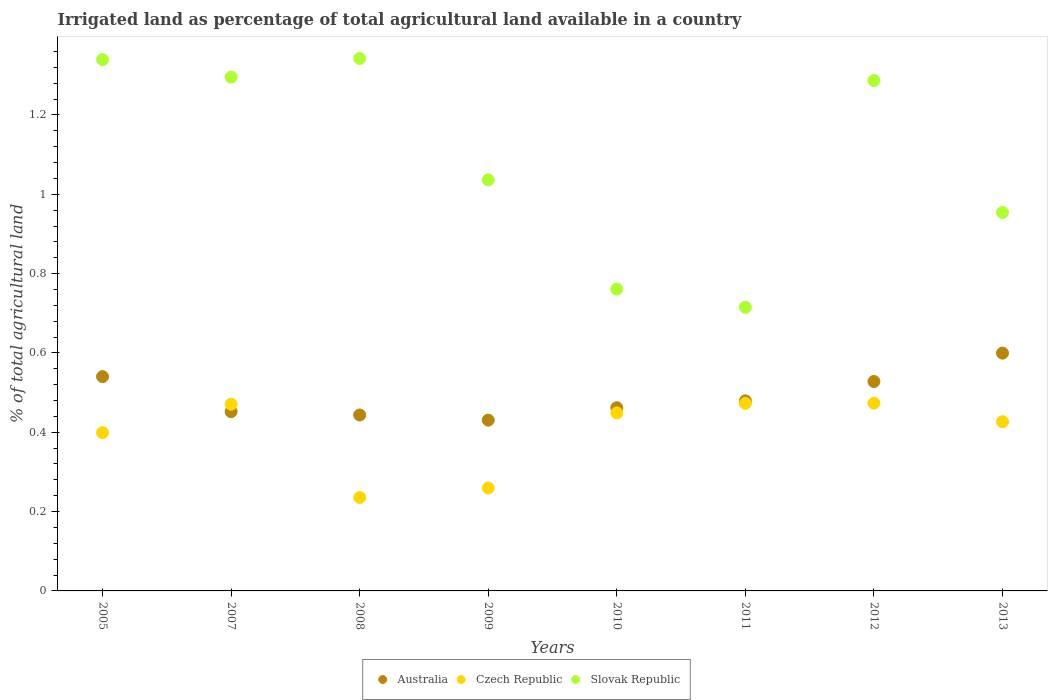How many different coloured dotlines are there?
Keep it short and to the point. 3. What is the percentage of irrigated land in Australia in 2010?
Provide a succinct answer. 0.46. Across all years, what is the maximum percentage of irrigated land in Australia?
Offer a very short reply. 0.6. Across all years, what is the minimum percentage of irrigated land in Australia?
Keep it short and to the point. 0.43. In which year was the percentage of irrigated land in Australia maximum?
Give a very brief answer. 2013. What is the total percentage of irrigated land in Australia in the graph?
Ensure brevity in your answer.  3.94. What is the difference between the percentage of irrigated land in Slovak Republic in 2011 and that in 2012?
Your response must be concise. -0.57. What is the difference between the percentage of irrigated land in Slovak Republic in 2009 and the percentage of irrigated land in Czech Republic in 2010?
Give a very brief answer. 0.59. What is the average percentage of irrigated land in Slovak Republic per year?
Provide a succinct answer. 1.09. In the year 2009, what is the difference between the percentage of irrigated land in Australia and percentage of irrigated land in Czech Republic?
Give a very brief answer. 0.17. What is the ratio of the percentage of irrigated land in Slovak Republic in 2008 to that in 2009?
Give a very brief answer. 1.3. Is the percentage of irrigated land in Slovak Republic in 2005 less than that in 2010?
Offer a terse response. No. Is the difference between the percentage of irrigated land in Australia in 2005 and 2007 greater than the difference between the percentage of irrigated land in Czech Republic in 2005 and 2007?
Make the answer very short. Yes. What is the difference between the highest and the second highest percentage of irrigated land in Czech Republic?
Your response must be concise. 0. What is the difference between the highest and the lowest percentage of irrigated land in Australia?
Provide a short and direct response. 0.17. In how many years, is the percentage of irrigated land in Australia greater than the average percentage of irrigated land in Australia taken over all years?
Keep it short and to the point. 3. Is the sum of the percentage of irrigated land in Australia in 2005 and 2007 greater than the maximum percentage of irrigated land in Czech Republic across all years?
Your answer should be very brief. Yes. Does the percentage of irrigated land in Czech Republic monotonically increase over the years?
Provide a succinct answer. No. Is the percentage of irrigated land in Australia strictly greater than the percentage of irrigated land in Slovak Republic over the years?
Your response must be concise. No. Does the graph contain any zero values?
Your answer should be very brief. No. Where does the legend appear in the graph?
Your answer should be compact. Bottom center. What is the title of the graph?
Provide a succinct answer. Irrigated land as percentage of total agricultural land available in a country. Does "Cuba" appear as one of the legend labels in the graph?
Provide a succinct answer. No. What is the label or title of the X-axis?
Give a very brief answer. Years. What is the label or title of the Y-axis?
Your answer should be compact. % of total agricultural land. What is the % of total agricultural land in Australia in 2005?
Ensure brevity in your answer.  0.54. What is the % of total agricultural land in Czech Republic in 2005?
Offer a very short reply. 0.4. What is the % of total agricultural land in Slovak Republic in 2005?
Keep it short and to the point. 1.34. What is the % of total agricultural land in Australia in 2007?
Provide a succinct answer. 0.45. What is the % of total agricultural land of Czech Republic in 2007?
Your answer should be very brief. 0.47. What is the % of total agricultural land of Slovak Republic in 2007?
Make the answer very short. 1.3. What is the % of total agricultural land in Australia in 2008?
Provide a short and direct response. 0.44. What is the % of total agricultural land of Czech Republic in 2008?
Make the answer very short. 0.24. What is the % of total agricultural land in Slovak Republic in 2008?
Offer a very short reply. 1.34. What is the % of total agricultural land of Australia in 2009?
Keep it short and to the point. 0.43. What is the % of total agricultural land in Czech Republic in 2009?
Your answer should be compact. 0.26. What is the % of total agricultural land of Slovak Republic in 2009?
Make the answer very short. 1.04. What is the % of total agricultural land of Australia in 2010?
Provide a succinct answer. 0.46. What is the % of total agricultural land of Czech Republic in 2010?
Provide a succinct answer. 0.45. What is the % of total agricultural land in Slovak Republic in 2010?
Provide a succinct answer. 0.76. What is the % of total agricultural land in Australia in 2011?
Your answer should be very brief. 0.48. What is the % of total agricultural land of Czech Republic in 2011?
Offer a terse response. 0.47. What is the % of total agricultural land in Slovak Republic in 2011?
Your response must be concise. 0.72. What is the % of total agricultural land in Australia in 2012?
Ensure brevity in your answer.  0.53. What is the % of total agricultural land in Czech Republic in 2012?
Provide a short and direct response. 0.47. What is the % of total agricultural land in Slovak Republic in 2012?
Give a very brief answer. 1.29. What is the % of total agricultural land in Australia in 2013?
Provide a short and direct response. 0.6. What is the % of total agricultural land of Czech Republic in 2013?
Offer a terse response. 0.43. What is the % of total agricultural land in Slovak Republic in 2013?
Ensure brevity in your answer.  0.95. Across all years, what is the maximum % of total agricultural land of Australia?
Provide a short and direct response. 0.6. Across all years, what is the maximum % of total agricultural land in Czech Republic?
Your response must be concise. 0.47. Across all years, what is the maximum % of total agricultural land of Slovak Republic?
Your response must be concise. 1.34. Across all years, what is the minimum % of total agricultural land in Australia?
Your answer should be compact. 0.43. Across all years, what is the minimum % of total agricultural land in Czech Republic?
Give a very brief answer. 0.24. Across all years, what is the minimum % of total agricultural land in Slovak Republic?
Offer a terse response. 0.72. What is the total % of total agricultural land of Australia in the graph?
Ensure brevity in your answer.  3.94. What is the total % of total agricultural land in Czech Republic in the graph?
Give a very brief answer. 3.19. What is the total % of total agricultural land of Slovak Republic in the graph?
Offer a terse response. 8.73. What is the difference between the % of total agricultural land of Australia in 2005 and that in 2007?
Ensure brevity in your answer.  0.09. What is the difference between the % of total agricultural land in Czech Republic in 2005 and that in 2007?
Your answer should be compact. -0.07. What is the difference between the % of total agricultural land of Slovak Republic in 2005 and that in 2007?
Your response must be concise. 0.04. What is the difference between the % of total agricultural land in Australia in 2005 and that in 2008?
Give a very brief answer. 0.1. What is the difference between the % of total agricultural land of Czech Republic in 2005 and that in 2008?
Offer a terse response. 0.16. What is the difference between the % of total agricultural land in Slovak Republic in 2005 and that in 2008?
Provide a succinct answer. -0. What is the difference between the % of total agricultural land in Australia in 2005 and that in 2009?
Your response must be concise. 0.11. What is the difference between the % of total agricultural land in Czech Republic in 2005 and that in 2009?
Your answer should be very brief. 0.14. What is the difference between the % of total agricultural land of Slovak Republic in 2005 and that in 2009?
Keep it short and to the point. 0.3. What is the difference between the % of total agricultural land in Australia in 2005 and that in 2010?
Make the answer very short. 0.08. What is the difference between the % of total agricultural land of Czech Republic in 2005 and that in 2010?
Offer a terse response. -0.05. What is the difference between the % of total agricultural land in Slovak Republic in 2005 and that in 2010?
Your response must be concise. 0.58. What is the difference between the % of total agricultural land of Australia in 2005 and that in 2011?
Give a very brief answer. 0.06. What is the difference between the % of total agricultural land of Czech Republic in 2005 and that in 2011?
Offer a terse response. -0.07. What is the difference between the % of total agricultural land of Slovak Republic in 2005 and that in 2011?
Your response must be concise. 0.62. What is the difference between the % of total agricultural land in Australia in 2005 and that in 2012?
Your answer should be compact. 0.01. What is the difference between the % of total agricultural land of Czech Republic in 2005 and that in 2012?
Ensure brevity in your answer.  -0.07. What is the difference between the % of total agricultural land in Slovak Republic in 2005 and that in 2012?
Make the answer very short. 0.05. What is the difference between the % of total agricultural land of Australia in 2005 and that in 2013?
Keep it short and to the point. -0.06. What is the difference between the % of total agricultural land of Czech Republic in 2005 and that in 2013?
Keep it short and to the point. -0.03. What is the difference between the % of total agricultural land of Slovak Republic in 2005 and that in 2013?
Your answer should be very brief. 0.39. What is the difference between the % of total agricultural land in Australia in 2007 and that in 2008?
Make the answer very short. 0.01. What is the difference between the % of total agricultural land in Czech Republic in 2007 and that in 2008?
Make the answer very short. 0.24. What is the difference between the % of total agricultural land in Slovak Republic in 2007 and that in 2008?
Keep it short and to the point. -0.05. What is the difference between the % of total agricultural land of Australia in 2007 and that in 2009?
Your response must be concise. 0.02. What is the difference between the % of total agricultural land of Czech Republic in 2007 and that in 2009?
Your answer should be compact. 0.21. What is the difference between the % of total agricultural land of Slovak Republic in 2007 and that in 2009?
Your response must be concise. 0.26. What is the difference between the % of total agricultural land in Australia in 2007 and that in 2010?
Provide a succinct answer. -0.01. What is the difference between the % of total agricultural land of Czech Republic in 2007 and that in 2010?
Keep it short and to the point. 0.02. What is the difference between the % of total agricultural land in Slovak Republic in 2007 and that in 2010?
Your answer should be compact. 0.53. What is the difference between the % of total agricultural land of Australia in 2007 and that in 2011?
Ensure brevity in your answer.  -0.03. What is the difference between the % of total agricultural land in Czech Republic in 2007 and that in 2011?
Give a very brief answer. -0. What is the difference between the % of total agricultural land in Slovak Republic in 2007 and that in 2011?
Your response must be concise. 0.58. What is the difference between the % of total agricultural land in Australia in 2007 and that in 2012?
Offer a very short reply. -0.08. What is the difference between the % of total agricultural land of Czech Republic in 2007 and that in 2012?
Make the answer very short. -0. What is the difference between the % of total agricultural land in Slovak Republic in 2007 and that in 2012?
Provide a short and direct response. 0.01. What is the difference between the % of total agricultural land in Australia in 2007 and that in 2013?
Keep it short and to the point. -0.15. What is the difference between the % of total agricultural land in Czech Republic in 2007 and that in 2013?
Keep it short and to the point. 0.04. What is the difference between the % of total agricultural land in Slovak Republic in 2007 and that in 2013?
Provide a short and direct response. 0.34. What is the difference between the % of total agricultural land of Australia in 2008 and that in 2009?
Provide a succinct answer. 0.01. What is the difference between the % of total agricultural land in Czech Republic in 2008 and that in 2009?
Offer a terse response. -0.02. What is the difference between the % of total agricultural land of Slovak Republic in 2008 and that in 2009?
Make the answer very short. 0.31. What is the difference between the % of total agricultural land of Australia in 2008 and that in 2010?
Ensure brevity in your answer.  -0.02. What is the difference between the % of total agricultural land in Czech Republic in 2008 and that in 2010?
Offer a terse response. -0.21. What is the difference between the % of total agricultural land in Slovak Republic in 2008 and that in 2010?
Your response must be concise. 0.58. What is the difference between the % of total agricultural land in Australia in 2008 and that in 2011?
Your answer should be very brief. -0.04. What is the difference between the % of total agricultural land of Czech Republic in 2008 and that in 2011?
Provide a short and direct response. -0.24. What is the difference between the % of total agricultural land of Slovak Republic in 2008 and that in 2011?
Keep it short and to the point. 0.63. What is the difference between the % of total agricultural land of Australia in 2008 and that in 2012?
Your answer should be compact. -0.08. What is the difference between the % of total agricultural land of Czech Republic in 2008 and that in 2012?
Provide a short and direct response. -0.24. What is the difference between the % of total agricultural land of Slovak Republic in 2008 and that in 2012?
Offer a terse response. 0.06. What is the difference between the % of total agricultural land of Australia in 2008 and that in 2013?
Make the answer very short. -0.16. What is the difference between the % of total agricultural land in Czech Republic in 2008 and that in 2013?
Your response must be concise. -0.19. What is the difference between the % of total agricultural land of Slovak Republic in 2008 and that in 2013?
Provide a succinct answer. 0.39. What is the difference between the % of total agricultural land in Australia in 2009 and that in 2010?
Offer a terse response. -0.03. What is the difference between the % of total agricultural land of Czech Republic in 2009 and that in 2010?
Your response must be concise. -0.19. What is the difference between the % of total agricultural land of Slovak Republic in 2009 and that in 2010?
Offer a very short reply. 0.28. What is the difference between the % of total agricultural land of Australia in 2009 and that in 2011?
Provide a succinct answer. -0.05. What is the difference between the % of total agricultural land of Czech Republic in 2009 and that in 2011?
Offer a very short reply. -0.21. What is the difference between the % of total agricultural land in Slovak Republic in 2009 and that in 2011?
Ensure brevity in your answer.  0.32. What is the difference between the % of total agricultural land of Australia in 2009 and that in 2012?
Give a very brief answer. -0.1. What is the difference between the % of total agricultural land in Czech Republic in 2009 and that in 2012?
Your answer should be compact. -0.21. What is the difference between the % of total agricultural land in Slovak Republic in 2009 and that in 2012?
Offer a terse response. -0.25. What is the difference between the % of total agricultural land in Australia in 2009 and that in 2013?
Offer a terse response. -0.17. What is the difference between the % of total agricultural land of Czech Republic in 2009 and that in 2013?
Give a very brief answer. -0.17. What is the difference between the % of total agricultural land of Slovak Republic in 2009 and that in 2013?
Give a very brief answer. 0.08. What is the difference between the % of total agricultural land in Australia in 2010 and that in 2011?
Your answer should be compact. -0.02. What is the difference between the % of total agricultural land of Czech Republic in 2010 and that in 2011?
Offer a terse response. -0.02. What is the difference between the % of total agricultural land in Slovak Republic in 2010 and that in 2011?
Offer a terse response. 0.05. What is the difference between the % of total agricultural land in Australia in 2010 and that in 2012?
Ensure brevity in your answer.  -0.07. What is the difference between the % of total agricultural land of Czech Republic in 2010 and that in 2012?
Give a very brief answer. -0.02. What is the difference between the % of total agricultural land of Slovak Republic in 2010 and that in 2012?
Keep it short and to the point. -0.53. What is the difference between the % of total agricultural land of Australia in 2010 and that in 2013?
Provide a succinct answer. -0.14. What is the difference between the % of total agricultural land of Czech Republic in 2010 and that in 2013?
Make the answer very short. 0.02. What is the difference between the % of total agricultural land of Slovak Republic in 2010 and that in 2013?
Offer a terse response. -0.19. What is the difference between the % of total agricultural land in Australia in 2011 and that in 2012?
Offer a very short reply. -0.05. What is the difference between the % of total agricultural land of Czech Republic in 2011 and that in 2012?
Make the answer very short. -0. What is the difference between the % of total agricultural land of Slovak Republic in 2011 and that in 2012?
Offer a terse response. -0.57. What is the difference between the % of total agricultural land in Australia in 2011 and that in 2013?
Offer a very short reply. -0.12. What is the difference between the % of total agricultural land of Czech Republic in 2011 and that in 2013?
Keep it short and to the point. 0.05. What is the difference between the % of total agricultural land of Slovak Republic in 2011 and that in 2013?
Provide a short and direct response. -0.24. What is the difference between the % of total agricultural land of Australia in 2012 and that in 2013?
Your answer should be compact. -0.07. What is the difference between the % of total agricultural land in Czech Republic in 2012 and that in 2013?
Give a very brief answer. 0.05. What is the difference between the % of total agricultural land of Slovak Republic in 2012 and that in 2013?
Ensure brevity in your answer.  0.33. What is the difference between the % of total agricultural land of Australia in 2005 and the % of total agricultural land of Czech Republic in 2007?
Provide a short and direct response. 0.07. What is the difference between the % of total agricultural land of Australia in 2005 and the % of total agricultural land of Slovak Republic in 2007?
Make the answer very short. -0.76. What is the difference between the % of total agricultural land in Czech Republic in 2005 and the % of total agricultural land in Slovak Republic in 2007?
Your answer should be very brief. -0.9. What is the difference between the % of total agricultural land in Australia in 2005 and the % of total agricultural land in Czech Republic in 2008?
Your answer should be compact. 0.3. What is the difference between the % of total agricultural land in Australia in 2005 and the % of total agricultural land in Slovak Republic in 2008?
Provide a succinct answer. -0.8. What is the difference between the % of total agricultural land of Czech Republic in 2005 and the % of total agricultural land of Slovak Republic in 2008?
Your answer should be very brief. -0.94. What is the difference between the % of total agricultural land of Australia in 2005 and the % of total agricultural land of Czech Republic in 2009?
Your answer should be very brief. 0.28. What is the difference between the % of total agricultural land in Australia in 2005 and the % of total agricultural land in Slovak Republic in 2009?
Give a very brief answer. -0.5. What is the difference between the % of total agricultural land in Czech Republic in 2005 and the % of total agricultural land in Slovak Republic in 2009?
Ensure brevity in your answer.  -0.64. What is the difference between the % of total agricultural land of Australia in 2005 and the % of total agricultural land of Czech Republic in 2010?
Give a very brief answer. 0.09. What is the difference between the % of total agricultural land in Australia in 2005 and the % of total agricultural land in Slovak Republic in 2010?
Make the answer very short. -0.22. What is the difference between the % of total agricultural land of Czech Republic in 2005 and the % of total agricultural land of Slovak Republic in 2010?
Your answer should be compact. -0.36. What is the difference between the % of total agricultural land of Australia in 2005 and the % of total agricultural land of Czech Republic in 2011?
Your answer should be very brief. 0.07. What is the difference between the % of total agricultural land in Australia in 2005 and the % of total agricultural land in Slovak Republic in 2011?
Your answer should be very brief. -0.17. What is the difference between the % of total agricultural land of Czech Republic in 2005 and the % of total agricultural land of Slovak Republic in 2011?
Ensure brevity in your answer.  -0.32. What is the difference between the % of total agricultural land of Australia in 2005 and the % of total agricultural land of Czech Republic in 2012?
Keep it short and to the point. 0.07. What is the difference between the % of total agricultural land of Australia in 2005 and the % of total agricultural land of Slovak Republic in 2012?
Your answer should be compact. -0.75. What is the difference between the % of total agricultural land of Czech Republic in 2005 and the % of total agricultural land of Slovak Republic in 2012?
Ensure brevity in your answer.  -0.89. What is the difference between the % of total agricultural land in Australia in 2005 and the % of total agricultural land in Czech Republic in 2013?
Offer a very short reply. 0.11. What is the difference between the % of total agricultural land in Australia in 2005 and the % of total agricultural land in Slovak Republic in 2013?
Give a very brief answer. -0.41. What is the difference between the % of total agricultural land in Czech Republic in 2005 and the % of total agricultural land in Slovak Republic in 2013?
Make the answer very short. -0.56. What is the difference between the % of total agricultural land of Australia in 2007 and the % of total agricultural land of Czech Republic in 2008?
Your answer should be very brief. 0.22. What is the difference between the % of total agricultural land in Australia in 2007 and the % of total agricultural land in Slovak Republic in 2008?
Your answer should be compact. -0.89. What is the difference between the % of total agricultural land in Czech Republic in 2007 and the % of total agricultural land in Slovak Republic in 2008?
Provide a succinct answer. -0.87. What is the difference between the % of total agricultural land of Australia in 2007 and the % of total agricultural land of Czech Republic in 2009?
Your answer should be very brief. 0.19. What is the difference between the % of total agricultural land in Australia in 2007 and the % of total agricultural land in Slovak Republic in 2009?
Keep it short and to the point. -0.58. What is the difference between the % of total agricultural land in Czech Republic in 2007 and the % of total agricultural land in Slovak Republic in 2009?
Your answer should be very brief. -0.57. What is the difference between the % of total agricultural land of Australia in 2007 and the % of total agricultural land of Czech Republic in 2010?
Your answer should be very brief. 0. What is the difference between the % of total agricultural land of Australia in 2007 and the % of total agricultural land of Slovak Republic in 2010?
Provide a succinct answer. -0.31. What is the difference between the % of total agricultural land of Czech Republic in 2007 and the % of total agricultural land of Slovak Republic in 2010?
Provide a short and direct response. -0.29. What is the difference between the % of total agricultural land in Australia in 2007 and the % of total agricultural land in Czech Republic in 2011?
Your answer should be very brief. -0.02. What is the difference between the % of total agricultural land of Australia in 2007 and the % of total agricultural land of Slovak Republic in 2011?
Give a very brief answer. -0.26. What is the difference between the % of total agricultural land in Czech Republic in 2007 and the % of total agricultural land in Slovak Republic in 2011?
Offer a very short reply. -0.24. What is the difference between the % of total agricultural land of Australia in 2007 and the % of total agricultural land of Czech Republic in 2012?
Keep it short and to the point. -0.02. What is the difference between the % of total agricultural land of Australia in 2007 and the % of total agricultural land of Slovak Republic in 2012?
Offer a very short reply. -0.83. What is the difference between the % of total agricultural land in Czech Republic in 2007 and the % of total agricultural land in Slovak Republic in 2012?
Offer a terse response. -0.82. What is the difference between the % of total agricultural land in Australia in 2007 and the % of total agricultural land in Czech Republic in 2013?
Provide a short and direct response. 0.03. What is the difference between the % of total agricultural land in Australia in 2007 and the % of total agricultural land in Slovak Republic in 2013?
Provide a succinct answer. -0.5. What is the difference between the % of total agricultural land of Czech Republic in 2007 and the % of total agricultural land of Slovak Republic in 2013?
Ensure brevity in your answer.  -0.48. What is the difference between the % of total agricultural land in Australia in 2008 and the % of total agricultural land in Czech Republic in 2009?
Your answer should be very brief. 0.18. What is the difference between the % of total agricultural land of Australia in 2008 and the % of total agricultural land of Slovak Republic in 2009?
Give a very brief answer. -0.59. What is the difference between the % of total agricultural land in Czech Republic in 2008 and the % of total agricultural land in Slovak Republic in 2009?
Make the answer very short. -0.8. What is the difference between the % of total agricultural land in Australia in 2008 and the % of total agricultural land in Czech Republic in 2010?
Keep it short and to the point. -0.01. What is the difference between the % of total agricultural land of Australia in 2008 and the % of total agricultural land of Slovak Republic in 2010?
Provide a succinct answer. -0.32. What is the difference between the % of total agricultural land of Czech Republic in 2008 and the % of total agricultural land of Slovak Republic in 2010?
Make the answer very short. -0.53. What is the difference between the % of total agricultural land in Australia in 2008 and the % of total agricultural land in Czech Republic in 2011?
Make the answer very short. -0.03. What is the difference between the % of total agricultural land in Australia in 2008 and the % of total agricultural land in Slovak Republic in 2011?
Your answer should be compact. -0.27. What is the difference between the % of total agricultural land of Czech Republic in 2008 and the % of total agricultural land of Slovak Republic in 2011?
Make the answer very short. -0.48. What is the difference between the % of total agricultural land in Australia in 2008 and the % of total agricultural land in Czech Republic in 2012?
Offer a very short reply. -0.03. What is the difference between the % of total agricultural land of Australia in 2008 and the % of total agricultural land of Slovak Republic in 2012?
Give a very brief answer. -0.84. What is the difference between the % of total agricultural land in Czech Republic in 2008 and the % of total agricultural land in Slovak Republic in 2012?
Your answer should be very brief. -1.05. What is the difference between the % of total agricultural land in Australia in 2008 and the % of total agricultural land in Czech Republic in 2013?
Your answer should be compact. 0.02. What is the difference between the % of total agricultural land in Australia in 2008 and the % of total agricultural land in Slovak Republic in 2013?
Give a very brief answer. -0.51. What is the difference between the % of total agricultural land of Czech Republic in 2008 and the % of total agricultural land of Slovak Republic in 2013?
Your answer should be very brief. -0.72. What is the difference between the % of total agricultural land of Australia in 2009 and the % of total agricultural land of Czech Republic in 2010?
Make the answer very short. -0.02. What is the difference between the % of total agricultural land in Australia in 2009 and the % of total agricultural land in Slovak Republic in 2010?
Offer a terse response. -0.33. What is the difference between the % of total agricultural land in Czech Republic in 2009 and the % of total agricultural land in Slovak Republic in 2010?
Provide a succinct answer. -0.5. What is the difference between the % of total agricultural land of Australia in 2009 and the % of total agricultural land of Czech Republic in 2011?
Your answer should be very brief. -0.04. What is the difference between the % of total agricultural land of Australia in 2009 and the % of total agricultural land of Slovak Republic in 2011?
Make the answer very short. -0.28. What is the difference between the % of total agricultural land in Czech Republic in 2009 and the % of total agricultural land in Slovak Republic in 2011?
Offer a terse response. -0.46. What is the difference between the % of total agricultural land in Australia in 2009 and the % of total agricultural land in Czech Republic in 2012?
Make the answer very short. -0.04. What is the difference between the % of total agricultural land in Australia in 2009 and the % of total agricultural land in Slovak Republic in 2012?
Ensure brevity in your answer.  -0.86. What is the difference between the % of total agricultural land in Czech Republic in 2009 and the % of total agricultural land in Slovak Republic in 2012?
Provide a succinct answer. -1.03. What is the difference between the % of total agricultural land of Australia in 2009 and the % of total agricultural land of Czech Republic in 2013?
Your answer should be compact. 0. What is the difference between the % of total agricultural land in Australia in 2009 and the % of total agricultural land in Slovak Republic in 2013?
Provide a short and direct response. -0.52. What is the difference between the % of total agricultural land in Czech Republic in 2009 and the % of total agricultural land in Slovak Republic in 2013?
Provide a short and direct response. -0.69. What is the difference between the % of total agricultural land in Australia in 2010 and the % of total agricultural land in Czech Republic in 2011?
Your answer should be very brief. -0.01. What is the difference between the % of total agricultural land of Australia in 2010 and the % of total agricultural land of Slovak Republic in 2011?
Provide a succinct answer. -0.25. What is the difference between the % of total agricultural land in Czech Republic in 2010 and the % of total agricultural land in Slovak Republic in 2011?
Ensure brevity in your answer.  -0.27. What is the difference between the % of total agricultural land in Australia in 2010 and the % of total agricultural land in Czech Republic in 2012?
Ensure brevity in your answer.  -0.01. What is the difference between the % of total agricultural land of Australia in 2010 and the % of total agricultural land of Slovak Republic in 2012?
Give a very brief answer. -0.82. What is the difference between the % of total agricultural land in Czech Republic in 2010 and the % of total agricultural land in Slovak Republic in 2012?
Offer a very short reply. -0.84. What is the difference between the % of total agricultural land of Australia in 2010 and the % of total agricultural land of Czech Republic in 2013?
Offer a very short reply. 0.04. What is the difference between the % of total agricultural land in Australia in 2010 and the % of total agricultural land in Slovak Republic in 2013?
Your response must be concise. -0.49. What is the difference between the % of total agricultural land in Czech Republic in 2010 and the % of total agricultural land in Slovak Republic in 2013?
Provide a short and direct response. -0.51. What is the difference between the % of total agricultural land in Australia in 2011 and the % of total agricultural land in Czech Republic in 2012?
Offer a very short reply. 0.01. What is the difference between the % of total agricultural land of Australia in 2011 and the % of total agricultural land of Slovak Republic in 2012?
Ensure brevity in your answer.  -0.81. What is the difference between the % of total agricultural land in Czech Republic in 2011 and the % of total agricultural land in Slovak Republic in 2012?
Your answer should be very brief. -0.81. What is the difference between the % of total agricultural land in Australia in 2011 and the % of total agricultural land in Czech Republic in 2013?
Your response must be concise. 0.05. What is the difference between the % of total agricultural land of Australia in 2011 and the % of total agricultural land of Slovak Republic in 2013?
Make the answer very short. -0.47. What is the difference between the % of total agricultural land in Czech Republic in 2011 and the % of total agricultural land in Slovak Republic in 2013?
Your answer should be compact. -0.48. What is the difference between the % of total agricultural land of Australia in 2012 and the % of total agricultural land of Czech Republic in 2013?
Give a very brief answer. 0.1. What is the difference between the % of total agricultural land of Australia in 2012 and the % of total agricultural land of Slovak Republic in 2013?
Ensure brevity in your answer.  -0.43. What is the difference between the % of total agricultural land of Czech Republic in 2012 and the % of total agricultural land of Slovak Republic in 2013?
Provide a succinct answer. -0.48. What is the average % of total agricultural land in Australia per year?
Your response must be concise. 0.49. What is the average % of total agricultural land of Czech Republic per year?
Make the answer very short. 0.4. What is the average % of total agricultural land in Slovak Republic per year?
Your answer should be compact. 1.09. In the year 2005, what is the difference between the % of total agricultural land in Australia and % of total agricultural land in Czech Republic?
Your response must be concise. 0.14. In the year 2005, what is the difference between the % of total agricultural land of Australia and % of total agricultural land of Slovak Republic?
Your response must be concise. -0.8. In the year 2005, what is the difference between the % of total agricultural land of Czech Republic and % of total agricultural land of Slovak Republic?
Your answer should be very brief. -0.94. In the year 2007, what is the difference between the % of total agricultural land in Australia and % of total agricultural land in Czech Republic?
Ensure brevity in your answer.  -0.02. In the year 2007, what is the difference between the % of total agricultural land in Australia and % of total agricultural land in Slovak Republic?
Keep it short and to the point. -0.84. In the year 2007, what is the difference between the % of total agricultural land in Czech Republic and % of total agricultural land in Slovak Republic?
Give a very brief answer. -0.82. In the year 2008, what is the difference between the % of total agricultural land of Australia and % of total agricultural land of Czech Republic?
Your answer should be compact. 0.21. In the year 2008, what is the difference between the % of total agricultural land in Australia and % of total agricultural land in Slovak Republic?
Your answer should be compact. -0.9. In the year 2008, what is the difference between the % of total agricultural land in Czech Republic and % of total agricultural land in Slovak Republic?
Your answer should be compact. -1.11. In the year 2009, what is the difference between the % of total agricultural land in Australia and % of total agricultural land in Czech Republic?
Your response must be concise. 0.17. In the year 2009, what is the difference between the % of total agricultural land in Australia and % of total agricultural land in Slovak Republic?
Ensure brevity in your answer.  -0.61. In the year 2009, what is the difference between the % of total agricultural land in Czech Republic and % of total agricultural land in Slovak Republic?
Offer a terse response. -0.78. In the year 2010, what is the difference between the % of total agricultural land of Australia and % of total agricultural land of Czech Republic?
Keep it short and to the point. 0.01. In the year 2010, what is the difference between the % of total agricultural land in Australia and % of total agricultural land in Slovak Republic?
Offer a very short reply. -0.3. In the year 2010, what is the difference between the % of total agricultural land of Czech Republic and % of total agricultural land of Slovak Republic?
Make the answer very short. -0.31. In the year 2011, what is the difference between the % of total agricultural land of Australia and % of total agricultural land of Czech Republic?
Offer a very short reply. 0.01. In the year 2011, what is the difference between the % of total agricultural land of Australia and % of total agricultural land of Slovak Republic?
Ensure brevity in your answer.  -0.24. In the year 2011, what is the difference between the % of total agricultural land in Czech Republic and % of total agricultural land in Slovak Republic?
Your response must be concise. -0.24. In the year 2012, what is the difference between the % of total agricultural land of Australia and % of total agricultural land of Czech Republic?
Provide a short and direct response. 0.05. In the year 2012, what is the difference between the % of total agricultural land in Australia and % of total agricultural land in Slovak Republic?
Keep it short and to the point. -0.76. In the year 2012, what is the difference between the % of total agricultural land in Czech Republic and % of total agricultural land in Slovak Republic?
Give a very brief answer. -0.81. In the year 2013, what is the difference between the % of total agricultural land in Australia and % of total agricultural land in Czech Republic?
Keep it short and to the point. 0.17. In the year 2013, what is the difference between the % of total agricultural land in Australia and % of total agricultural land in Slovak Republic?
Give a very brief answer. -0.35. In the year 2013, what is the difference between the % of total agricultural land of Czech Republic and % of total agricultural land of Slovak Republic?
Make the answer very short. -0.53. What is the ratio of the % of total agricultural land of Australia in 2005 to that in 2007?
Ensure brevity in your answer.  1.2. What is the ratio of the % of total agricultural land of Czech Republic in 2005 to that in 2007?
Your answer should be compact. 0.85. What is the ratio of the % of total agricultural land of Slovak Republic in 2005 to that in 2007?
Your answer should be very brief. 1.03. What is the ratio of the % of total agricultural land of Australia in 2005 to that in 2008?
Keep it short and to the point. 1.22. What is the ratio of the % of total agricultural land of Czech Republic in 2005 to that in 2008?
Offer a very short reply. 1.69. What is the ratio of the % of total agricultural land in Australia in 2005 to that in 2009?
Your answer should be very brief. 1.25. What is the ratio of the % of total agricultural land in Czech Republic in 2005 to that in 2009?
Ensure brevity in your answer.  1.54. What is the ratio of the % of total agricultural land of Slovak Republic in 2005 to that in 2009?
Offer a very short reply. 1.29. What is the ratio of the % of total agricultural land in Australia in 2005 to that in 2010?
Your answer should be very brief. 1.17. What is the ratio of the % of total agricultural land of Czech Republic in 2005 to that in 2010?
Offer a terse response. 0.89. What is the ratio of the % of total agricultural land of Slovak Republic in 2005 to that in 2010?
Your answer should be very brief. 1.76. What is the ratio of the % of total agricultural land of Australia in 2005 to that in 2011?
Ensure brevity in your answer.  1.13. What is the ratio of the % of total agricultural land in Czech Republic in 2005 to that in 2011?
Ensure brevity in your answer.  0.84. What is the ratio of the % of total agricultural land of Slovak Republic in 2005 to that in 2011?
Provide a short and direct response. 1.87. What is the ratio of the % of total agricultural land of Australia in 2005 to that in 2012?
Ensure brevity in your answer.  1.02. What is the ratio of the % of total agricultural land of Czech Republic in 2005 to that in 2012?
Give a very brief answer. 0.84. What is the ratio of the % of total agricultural land of Slovak Republic in 2005 to that in 2012?
Give a very brief answer. 1.04. What is the ratio of the % of total agricultural land of Australia in 2005 to that in 2013?
Keep it short and to the point. 0.9. What is the ratio of the % of total agricultural land in Czech Republic in 2005 to that in 2013?
Ensure brevity in your answer.  0.94. What is the ratio of the % of total agricultural land in Slovak Republic in 2005 to that in 2013?
Keep it short and to the point. 1.4. What is the ratio of the % of total agricultural land of Australia in 2007 to that in 2008?
Make the answer very short. 1.02. What is the ratio of the % of total agricultural land in Czech Republic in 2007 to that in 2008?
Keep it short and to the point. 2. What is the ratio of the % of total agricultural land in Slovak Republic in 2007 to that in 2008?
Provide a short and direct response. 0.96. What is the ratio of the % of total agricultural land of Australia in 2007 to that in 2009?
Ensure brevity in your answer.  1.05. What is the ratio of the % of total agricultural land of Czech Republic in 2007 to that in 2009?
Ensure brevity in your answer.  1.81. What is the ratio of the % of total agricultural land in Slovak Republic in 2007 to that in 2009?
Offer a terse response. 1.25. What is the ratio of the % of total agricultural land in Australia in 2007 to that in 2010?
Your answer should be very brief. 0.98. What is the ratio of the % of total agricultural land in Czech Republic in 2007 to that in 2010?
Offer a very short reply. 1.05. What is the ratio of the % of total agricultural land of Slovak Republic in 2007 to that in 2010?
Make the answer very short. 1.7. What is the ratio of the % of total agricultural land in Australia in 2007 to that in 2011?
Provide a short and direct response. 0.94. What is the ratio of the % of total agricultural land of Czech Republic in 2007 to that in 2011?
Provide a short and direct response. 1. What is the ratio of the % of total agricultural land in Slovak Republic in 2007 to that in 2011?
Provide a succinct answer. 1.81. What is the ratio of the % of total agricultural land in Australia in 2007 to that in 2012?
Provide a short and direct response. 0.86. What is the ratio of the % of total agricultural land in Czech Republic in 2007 to that in 2012?
Offer a very short reply. 0.99. What is the ratio of the % of total agricultural land in Slovak Republic in 2007 to that in 2012?
Provide a short and direct response. 1.01. What is the ratio of the % of total agricultural land in Australia in 2007 to that in 2013?
Your answer should be compact. 0.75. What is the ratio of the % of total agricultural land in Czech Republic in 2007 to that in 2013?
Your response must be concise. 1.1. What is the ratio of the % of total agricultural land of Slovak Republic in 2007 to that in 2013?
Provide a short and direct response. 1.36. What is the ratio of the % of total agricultural land in Australia in 2008 to that in 2009?
Ensure brevity in your answer.  1.03. What is the ratio of the % of total agricultural land in Czech Republic in 2008 to that in 2009?
Provide a short and direct response. 0.91. What is the ratio of the % of total agricultural land in Slovak Republic in 2008 to that in 2009?
Keep it short and to the point. 1.3. What is the ratio of the % of total agricultural land of Australia in 2008 to that in 2010?
Your answer should be compact. 0.96. What is the ratio of the % of total agricultural land in Czech Republic in 2008 to that in 2010?
Give a very brief answer. 0.53. What is the ratio of the % of total agricultural land of Slovak Republic in 2008 to that in 2010?
Give a very brief answer. 1.76. What is the ratio of the % of total agricultural land of Australia in 2008 to that in 2011?
Offer a terse response. 0.93. What is the ratio of the % of total agricultural land in Czech Republic in 2008 to that in 2011?
Keep it short and to the point. 0.5. What is the ratio of the % of total agricultural land of Slovak Republic in 2008 to that in 2011?
Your answer should be compact. 1.88. What is the ratio of the % of total agricultural land of Australia in 2008 to that in 2012?
Your answer should be very brief. 0.84. What is the ratio of the % of total agricultural land of Czech Republic in 2008 to that in 2012?
Your answer should be compact. 0.5. What is the ratio of the % of total agricultural land of Slovak Republic in 2008 to that in 2012?
Keep it short and to the point. 1.04. What is the ratio of the % of total agricultural land of Australia in 2008 to that in 2013?
Offer a terse response. 0.74. What is the ratio of the % of total agricultural land in Czech Republic in 2008 to that in 2013?
Your answer should be compact. 0.55. What is the ratio of the % of total agricultural land of Slovak Republic in 2008 to that in 2013?
Your answer should be very brief. 1.41. What is the ratio of the % of total agricultural land in Australia in 2009 to that in 2010?
Offer a terse response. 0.93. What is the ratio of the % of total agricultural land in Czech Republic in 2009 to that in 2010?
Your response must be concise. 0.58. What is the ratio of the % of total agricultural land in Slovak Republic in 2009 to that in 2010?
Your response must be concise. 1.36. What is the ratio of the % of total agricultural land of Australia in 2009 to that in 2011?
Offer a terse response. 0.9. What is the ratio of the % of total agricultural land of Czech Republic in 2009 to that in 2011?
Offer a very short reply. 0.55. What is the ratio of the % of total agricultural land of Slovak Republic in 2009 to that in 2011?
Provide a succinct answer. 1.45. What is the ratio of the % of total agricultural land of Australia in 2009 to that in 2012?
Offer a terse response. 0.82. What is the ratio of the % of total agricultural land in Czech Republic in 2009 to that in 2012?
Provide a succinct answer. 0.55. What is the ratio of the % of total agricultural land of Slovak Republic in 2009 to that in 2012?
Your answer should be very brief. 0.81. What is the ratio of the % of total agricultural land of Australia in 2009 to that in 2013?
Provide a short and direct response. 0.72. What is the ratio of the % of total agricultural land in Czech Republic in 2009 to that in 2013?
Your response must be concise. 0.61. What is the ratio of the % of total agricultural land of Slovak Republic in 2009 to that in 2013?
Your answer should be compact. 1.09. What is the ratio of the % of total agricultural land of Australia in 2010 to that in 2011?
Your answer should be very brief. 0.96. What is the ratio of the % of total agricultural land in Czech Republic in 2010 to that in 2011?
Keep it short and to the point. 0.95. What is the ratio of the % of total agricultural land in Slovak Republic in 2010 to that in 2011?
Ensure brevity in your answer.  1.06. What is the ratio of the % of total agricultural land of Australia in 2010 to that in 2012?
Your answer should be very brief. 0.87. What is the ratio of the % of total agricultural land of Czech Republic in 2010 to that in 2012?
Ensure brevity in your answer.  0.95. What is the ratio of the % of total agricultural land in Slovak Republic in 2010 to that in 2012?
Ensure brevity in your answer.  0.59. What is the ratio of the % of total agricultural land of Australia in 2010 to that in 2013?
Your answer should be compact. 0.77. What is the ratio of the % of total agricultural land of Czech Republic in 2010 to that in 2013?
Your answer should be compact. 1.05. What is the ratio of the % of total agricultural land of Slovak Republic in 2010 to that in 2013?
Offer a terse response. 0.8. What is the ratio of the % of total agricultural land of Australia in 2011 to that in 2012?
Your response must be concise. 0.91. What is the ratio of the % of total agricultural land in Slovak Republic in 2011 to that in 2012?
Provide a short and direct response. 0.56. What is the ratio of the % of total agricultural land of Australia in 2011 to that in 2013?
Make the answer very short. 0.8. What is the ratio of the % of total agricultural land of Czech Republic in 2011 to that in 2013?
Your response must be concise. 1.11. What is the ratio of the % of total agricultural land in Slovak Republic in 2011 to that in 2013?
Make the answer very short. 0.75. What is the ratio of the % of total agricultural land in Australia in 2012 to that in 2013?
Your answer should be very brief. 0.88. What is the ratio of the % of total agricultural land of Czech Republic in 2012 to that in 2013?
Offer a very short reply. 1.11. What is the ratio of the % of total agricultural land of Slovak Republic in 2012 to that in 2013?
Offer a terse response. 1.35. What is the difference between the highest and the second highest % of total agricultural land in Australia?
Your answer should be compact. 0.06. What is the difference between the highest and the second highest % of total agricultural land in Slovak Republic?
Keep it short and to the point. 0. What is the difference between the highest and the lowest % of total agricultural land of Australia?
Your response must be concise. 0.17. What is the difference between the highest and the lowest % of total agricultural land of Czech Republic?
Keep it short and to the point. 0.24. What is the difference between the highest and the lowest % of total agricultural land in Slovak Republic?
Your answer should be compact. 0.63. 